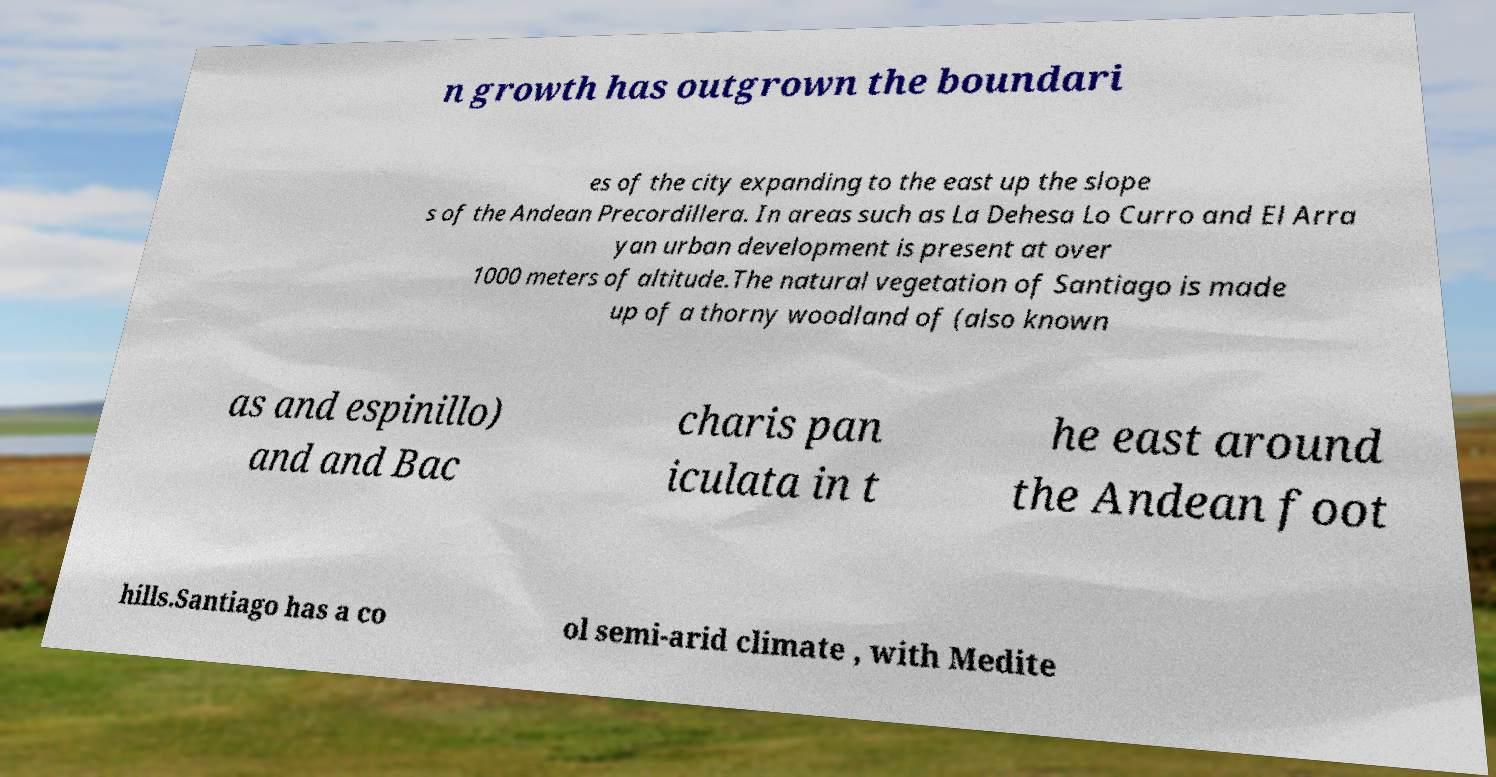Could you assist in decoding the text presented in this image and type it out clearly? n growth has outgrown the boundari es of the city expanding to the east up the slope s of the Andean Precordillera. In areas such as La Dehesa Lo Curro and El Arra yan urban development is present at over 1000 meters of altitude.The natural vegetation of Santiago is made up of a thorny woodland of (also known as and espinillo) and and Bac charis pan iculata in t he east around the Andean foot hills.Santiago has a co ol semi-arid climate , with Medite 